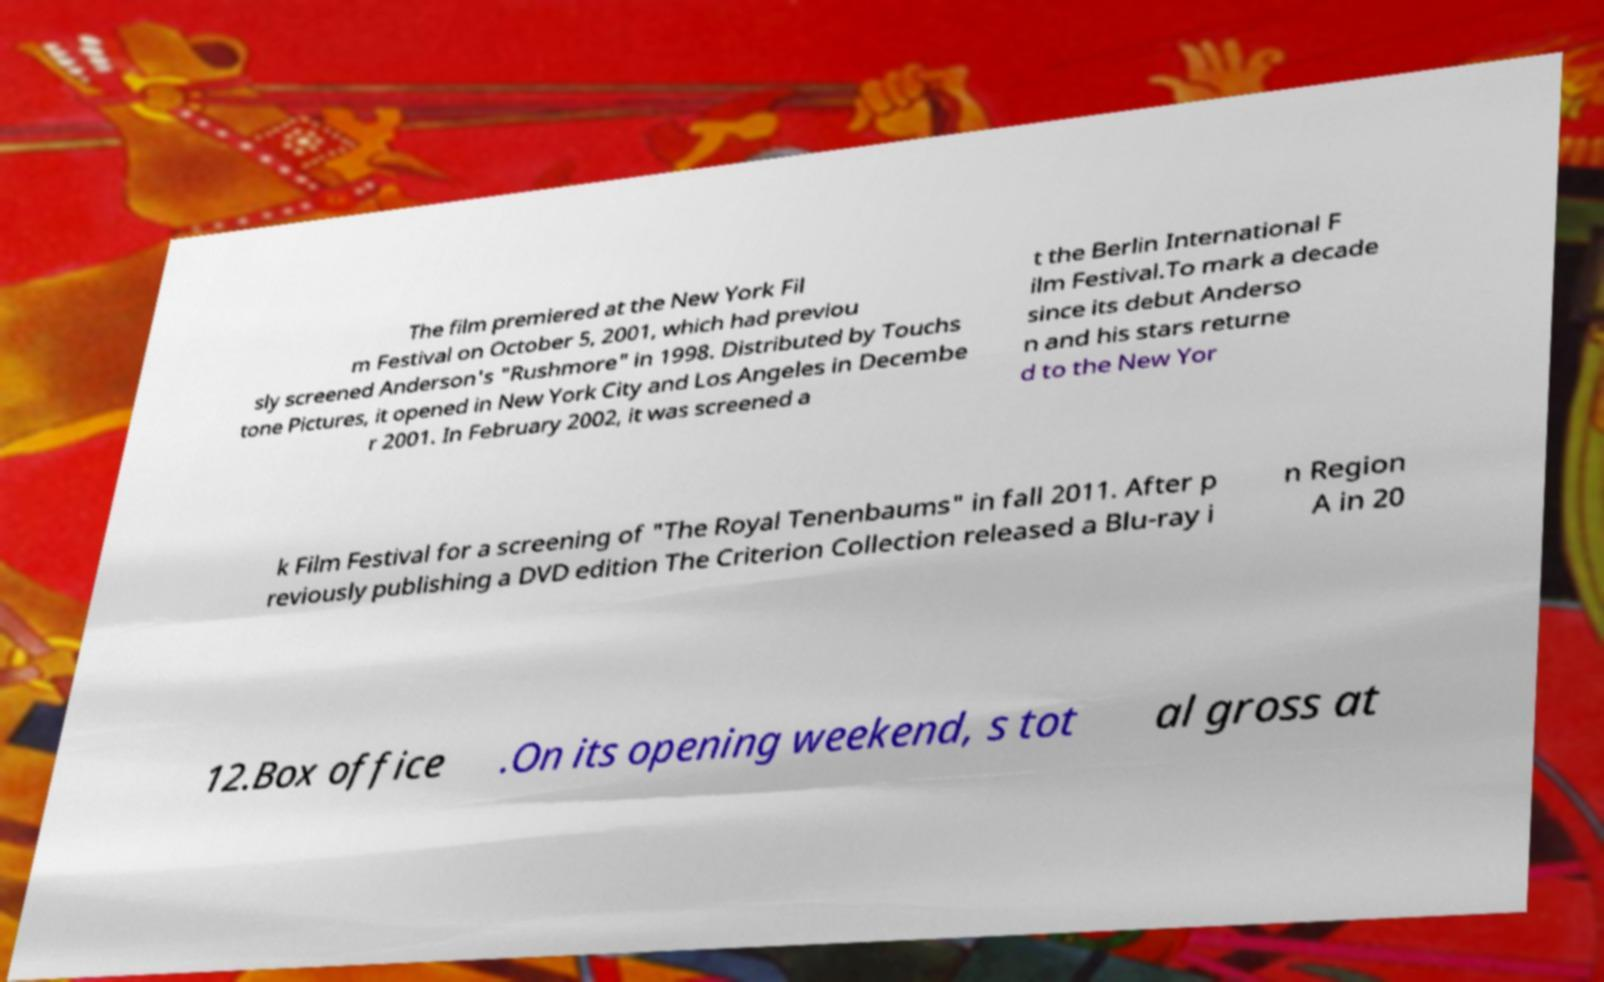Can you read and provide the text displayed in the image?This photo seems to have some interesting text. Can you extract and type it out for me? The film premiered at the New York Fil m Festival on October 5, 2001, which had previou sly screened Anderson's "Rushmore" in 1998. Distributed by Touchs tone Pictures, it opened in New York City and Los Angeles in Decembe r 2001. In February 2002, it was screened a t the Berlin International F ilm Festival.To mark a decade since its debut Anderso n and his stars returne d to the New Yor k Film Festival for a screening of "The Royal Tenenbaums" in fall 2011. After p reviously publishing a DVD edition The Criterion Collection released a Blu-ray i n Region A in 20 12.Box office .On its opening weekend, s tot al gross at 